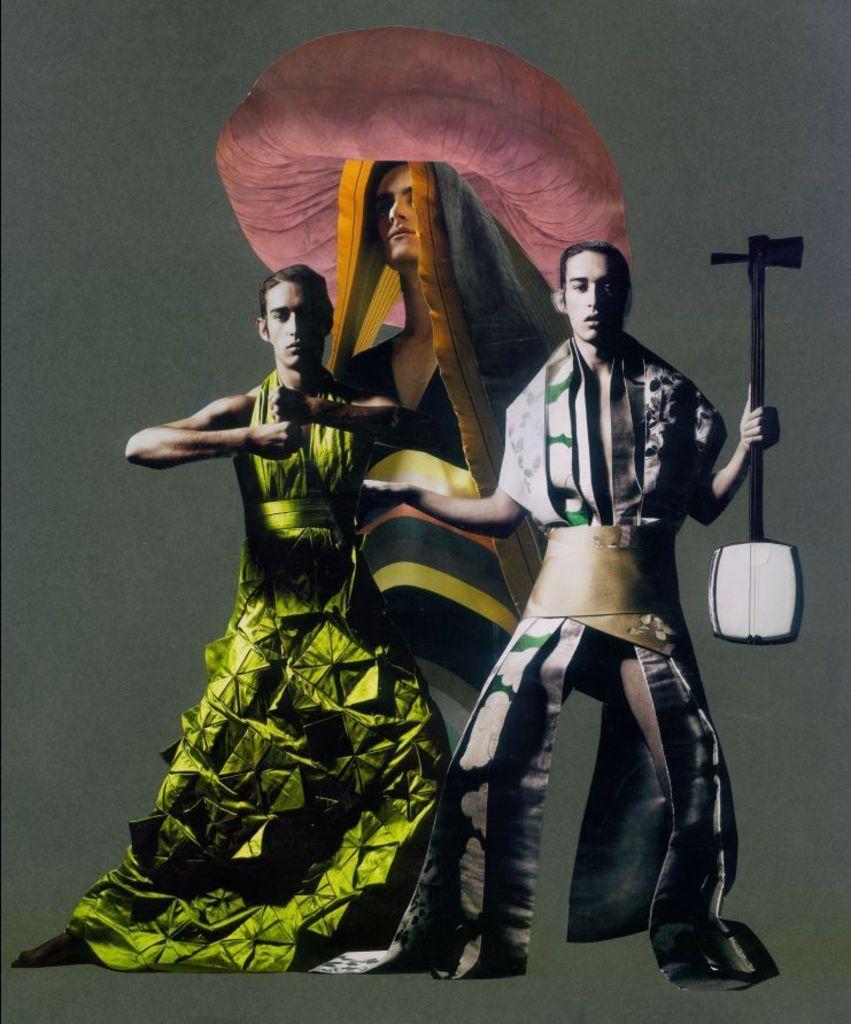Please provide a concise description of this image. In this image we can see two men standing on the surface wearing the costumes. In that a man is holding a tool. On the backside we can see the picture of a person on a wall. 